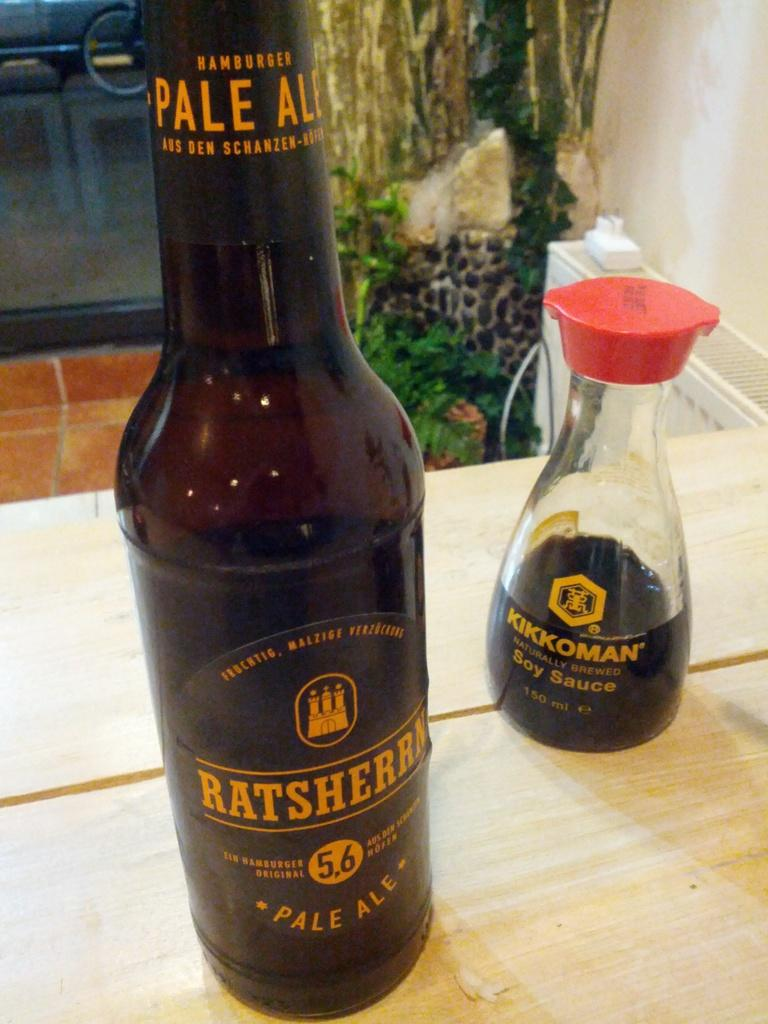<image>
Present a compact description of the photo's key features. A bottle of ale and a bottle of soy sauce are next to each other. 